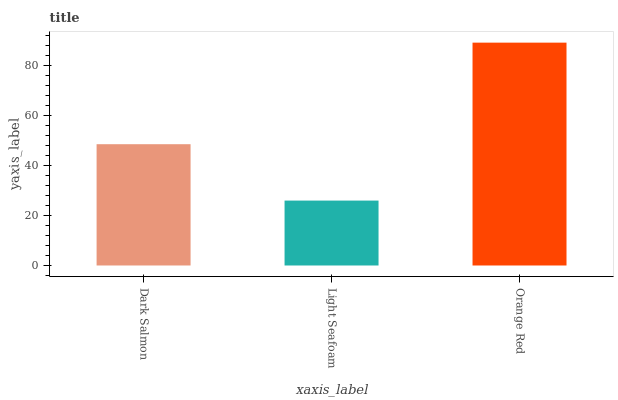Is Light Seafoam the minimum?
Answer yes or no. Yes. Is Orange Red the maximum?
Answer yes or no. Yes. Is Orange Red the minimum?
Answer yes or no. No. Is Light Seafoam the maximum?
Answer yes or no. No. Is Orange Red greater than Light Seafoam?
Answer yes or no. Yes. Is Light Seafoam less than Orange Red?
Answer yes or no. Yes. Is Light Seafoam greater than Orange Red?
Answer yes or no. No. Is Orange Red less than Light Seafoam?
Answer yes or no. No. Is Dark Salmon the high median?
Answer yes or no. Yes. Is Dark Salmon the low median?
Answer yes or no. Yes. Is Light Seafoam the high median?
Answer yes or no. No. Is Light Seafoam the low median?
Answer yes or no. No. 